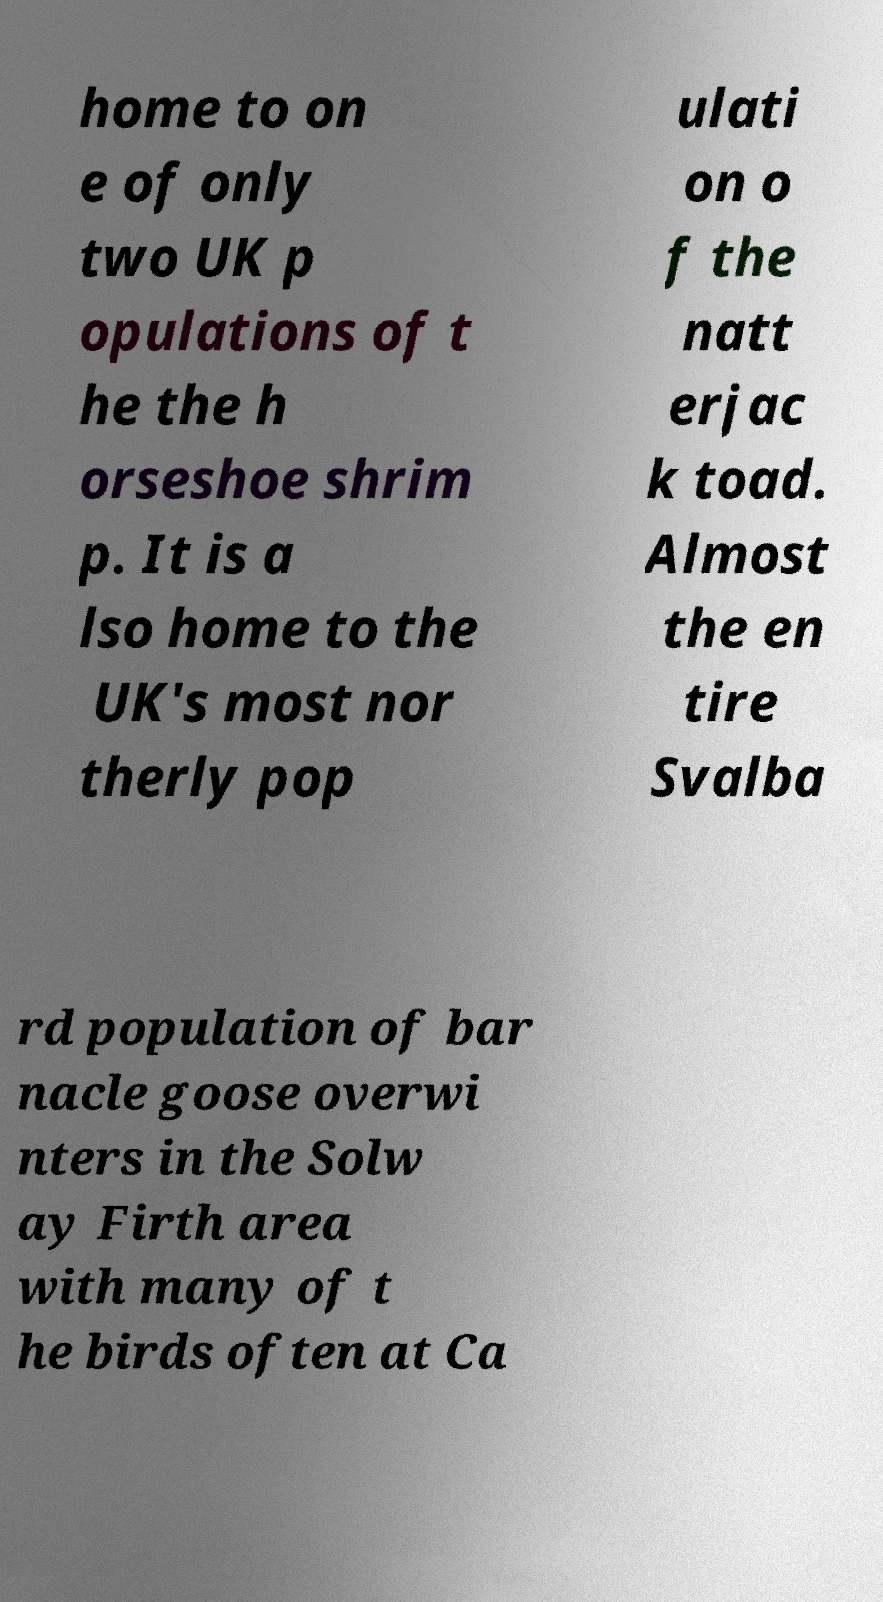Could you assist in decoding the text presented in this image and type it out clearly? home to on e of only two UK p opulations of t he the h orseshoe shrim p. It is a lso home to the UK's most nor therly pop ulati on o f the natt erjac k toad. Almost the en tire Svalba rd population of bar nacle goose overwi nters in the Solw ay Firth area with many of t he birds often at Ca 